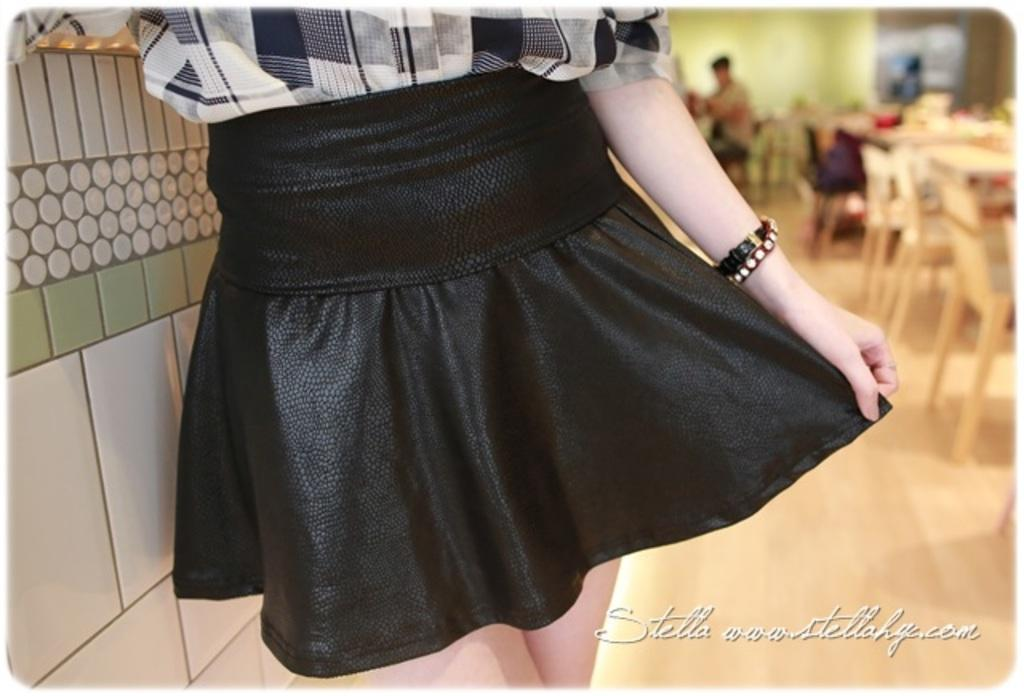Who is present in the image? There is a woman in the image. What type of furniture can be seen in the image? There are chairs and tables in the image. Can you describe the background of the image? There is a wall in the background of the image. How many people are in the image? There is one person in the image. What type of linen is draped over the chairs in the image? There is no linen draped over the chairs in the image; only chairs and tables are visible. 